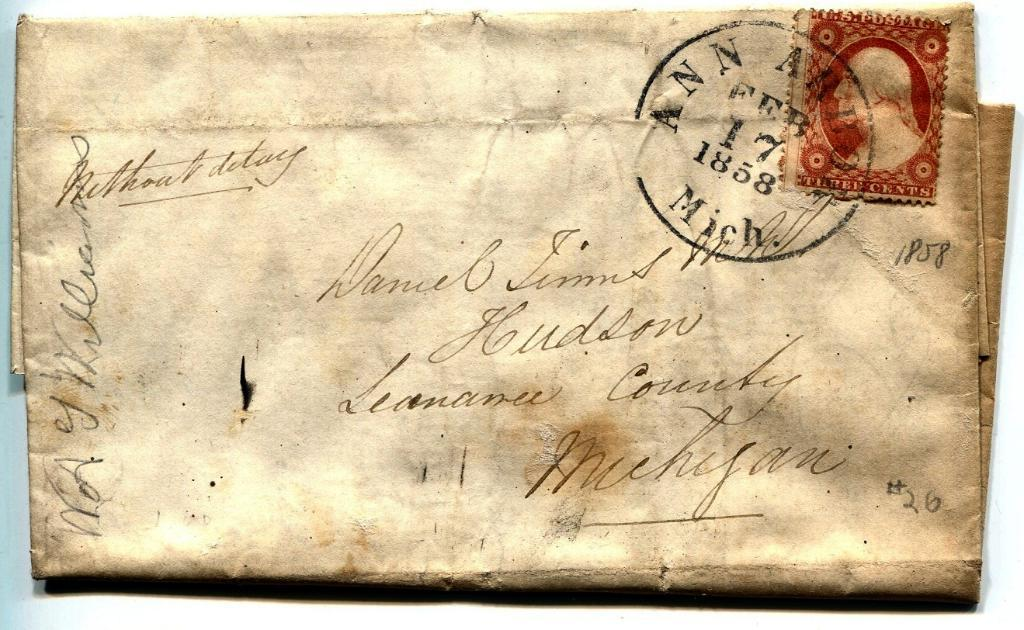<image>
Write a terse but informative summary of the picture. a very antique letter post marked Feb 17 1858 in Ann Arbor Mich. 